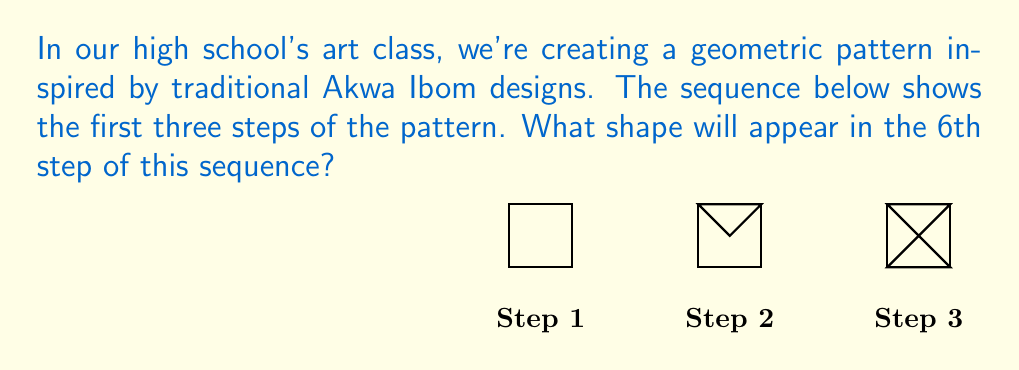Provide a solution to this math problem. To solve this problem, let's analyze the pattern step by step:

1) In Step 1, we start with a simple square.

2) In Step 2, a triangle is added to the top half of the square.

3) In Step 3, another triangle is added to the bottom half of the square.

4) We can infer that in each subsequent step, a new triangle is added, alternating between the top and bottom halves of the square.

5) Let's predict the next steps:
   - Step 4: Another triangle would be added to the top half.
   - Step 5: A triangle would be added to the bottom half.
   - Step 6: The final triangle would be added to the top half.

6) The pattern for triangle addition can be represented mathematically as:
   $$\text{Number of triangles} = \left\lfloor\frac{n-1}{2}\right\rfloor + \left\lceil\frac{n-1}{2}\right\rceil$$
   Where $n$ is the step number.

7) For Step 6:
   $$\text{Number of triangles} = \left\lfloor\frac{6-1}{2}\right\rfloor + \left\lceil\frac{6-1}{2}\right\rceil = 2 + 3 = 5$$

Therefore, in Step 6, the shape will be a square with 5 triangles: 3 in the top half and 2 in the bottom half.
Answer: A square with 5 triangles (3 top, 2 bottom) 